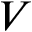<formula> <loc_0><loc_0><loc_500><loc_500>V</formula> 